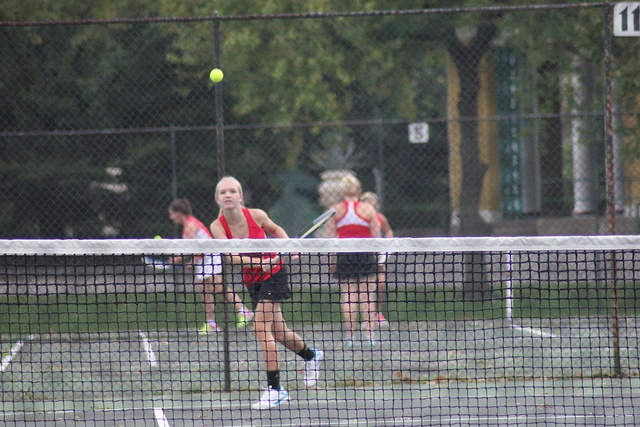Describe the objects in this image and their specific colors. I can see people in black, darkgray, lightpink, and gray tones, people in black, gray, darkgray, and lavender tones, people in black and gray tones, people in black, lightpink, darkgray, lavender, and brown tones, and people in black, gray, darkgray, and lightpink tones in this image. 